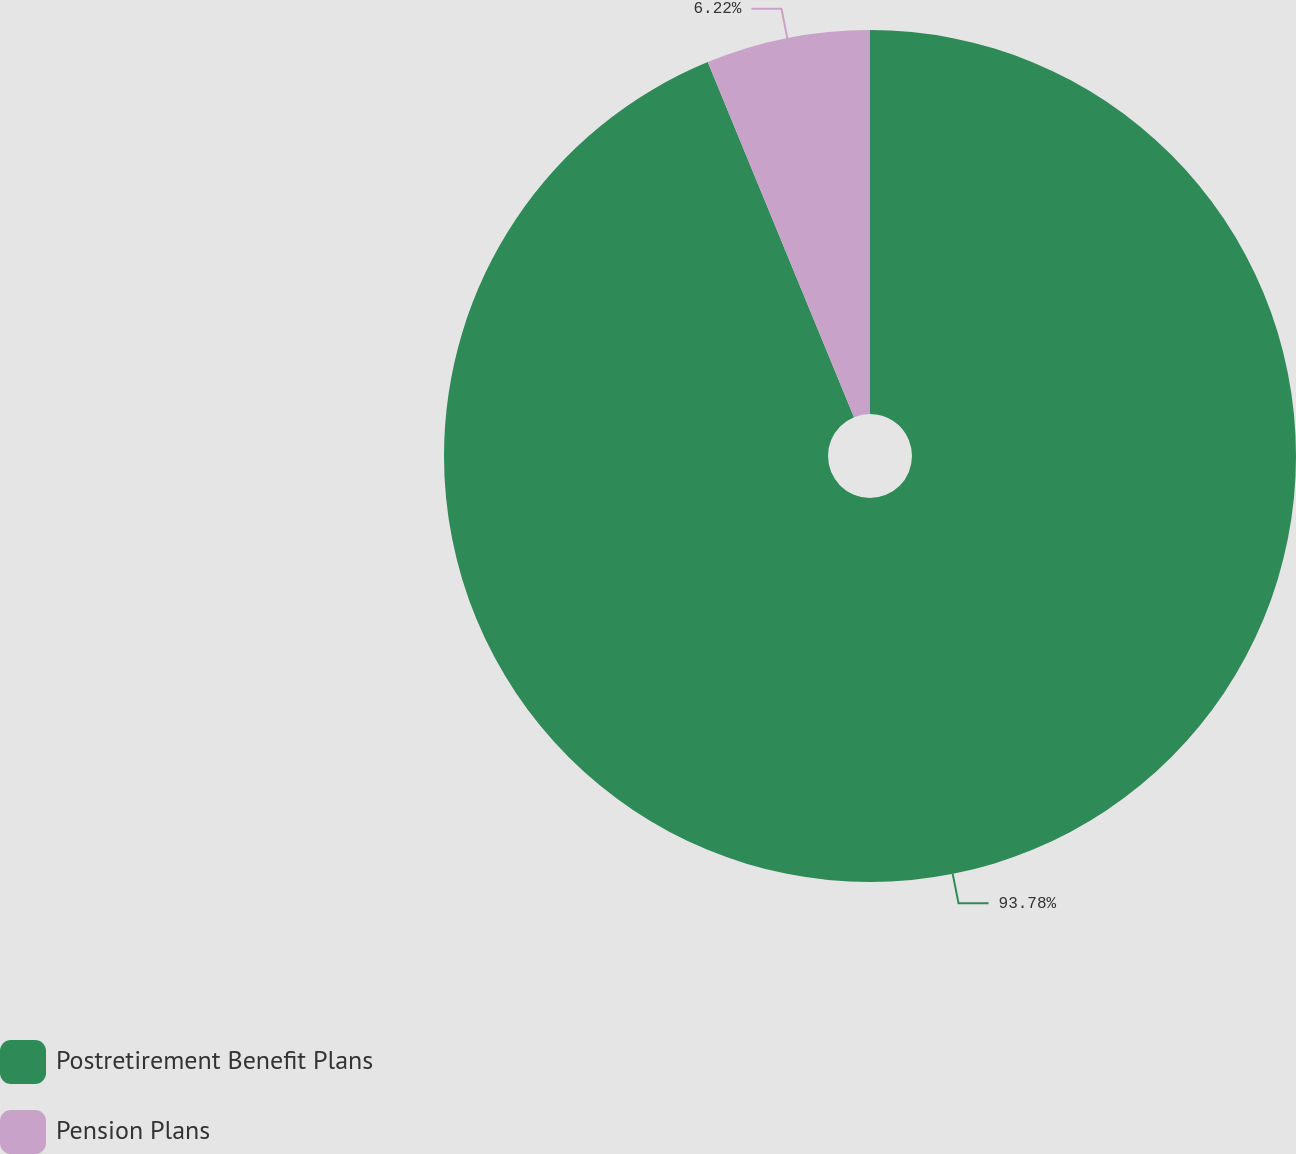Convert chart to OTSL. <chart><loc_0><loc_0><loc_500><loc_500><pie_chart><fcel>Postretirement Benefit Plans<fcel>Pension Plans<nl><fcel>93.78%<fcel>6.22%<nl></chart> 